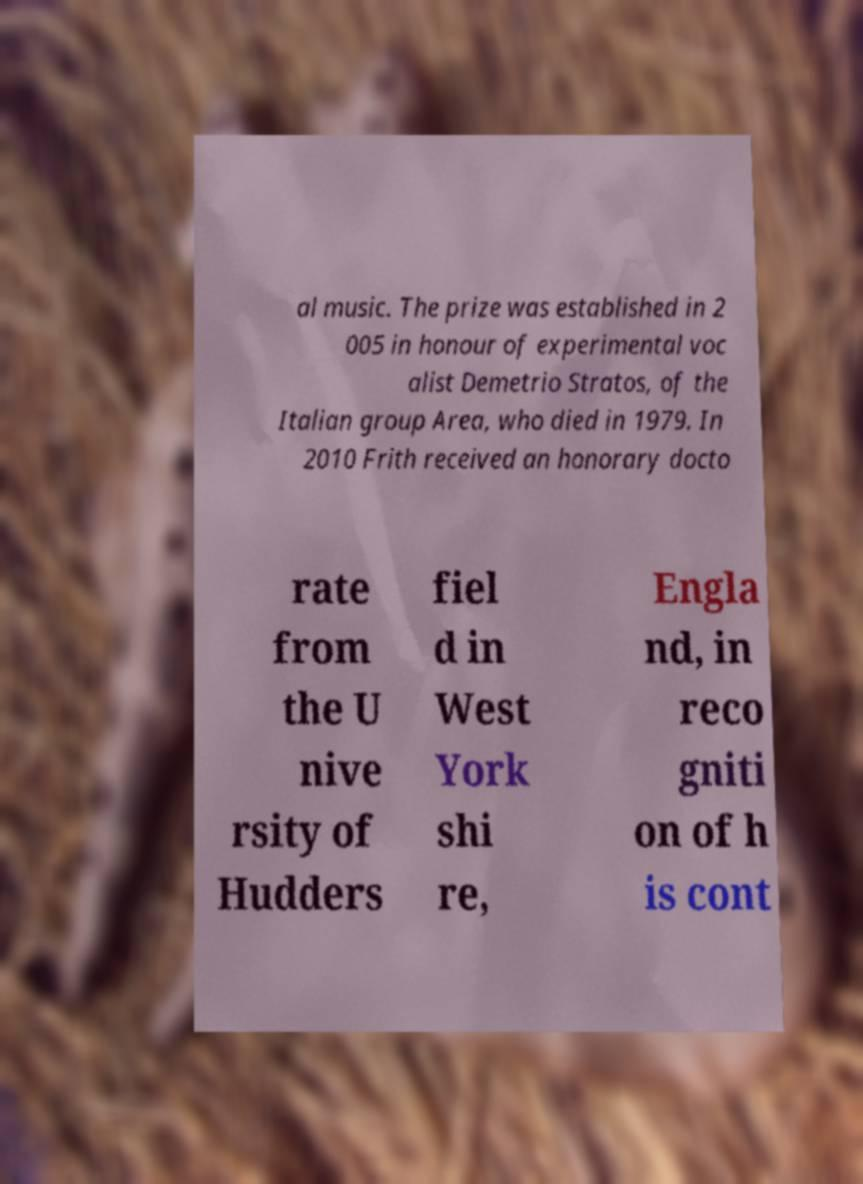Please read and relay the text visible in this image. What does it say? al music. The prize was established in 2 005 in honour of experimental voc alist Demetrio Stratos, of the Italian group Area, who died in 1979. In 2010 Frith received an honorary docto rate from the U nive rsity of Hudders fiel d in West York shi re, Engla nd, in reco gniti on of h is cont 